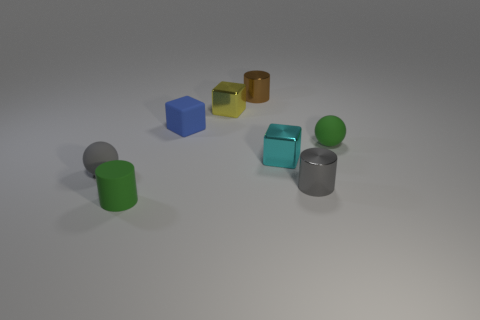Add 1 tiny blue rubber blocks. How many objects exist? 9 Subtract all cylinders. How many objects are left? 5 Subtract 0 purple blocks. How many objects are left? 8 Subtract all small shiny objects. Subtract all small blue rubber cubes. How many objects are left? 3 Add 2 cyan metallic things. How many cyan metallic things are left? 3 Add 2 blue matte cubes. How many blue matte cubes exist? 3 